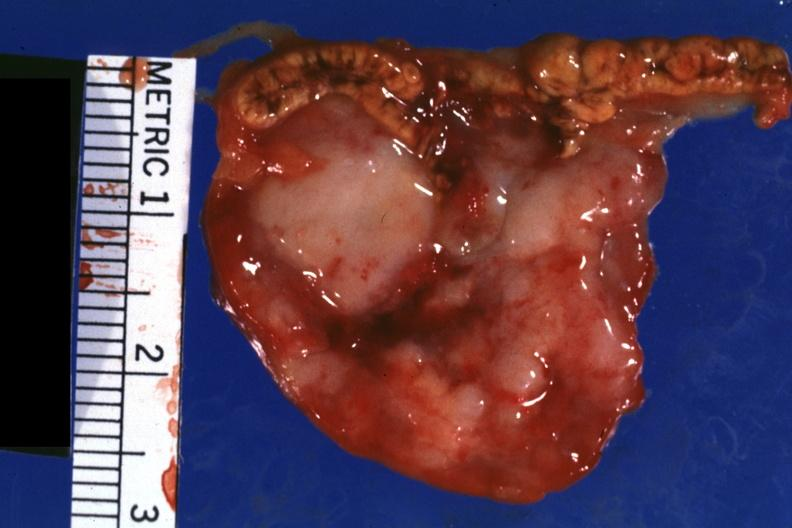what does this image show?
Answer the question using a single word or phrase. Close-up tumor is shown well 